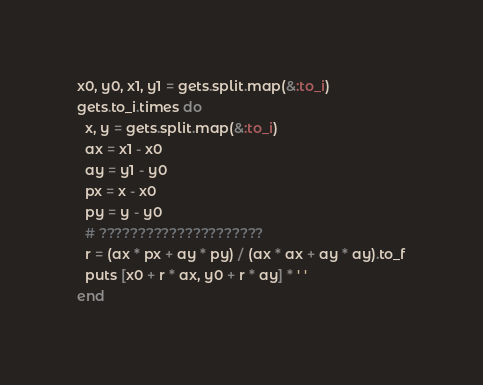Convert code to text. <code><loc_0><loc_0><loc_500><loc_500><_Ruby_>x0, y0, x1, y1 = gets.split.map(&:to_i)
gets.to_i.times do
  x, y = gets.split.map(&:to_i)
  ax = x1 - x0
  ay = y1 - y0
  px = x - x0
  py = y - y0
  # ?????????????????????
  r = (ax * px + ay * py) / (ax * ax + ay * ay).to_f
  puts [x0 + r * ax, y0 + r * ay] * ' '
end</code> 